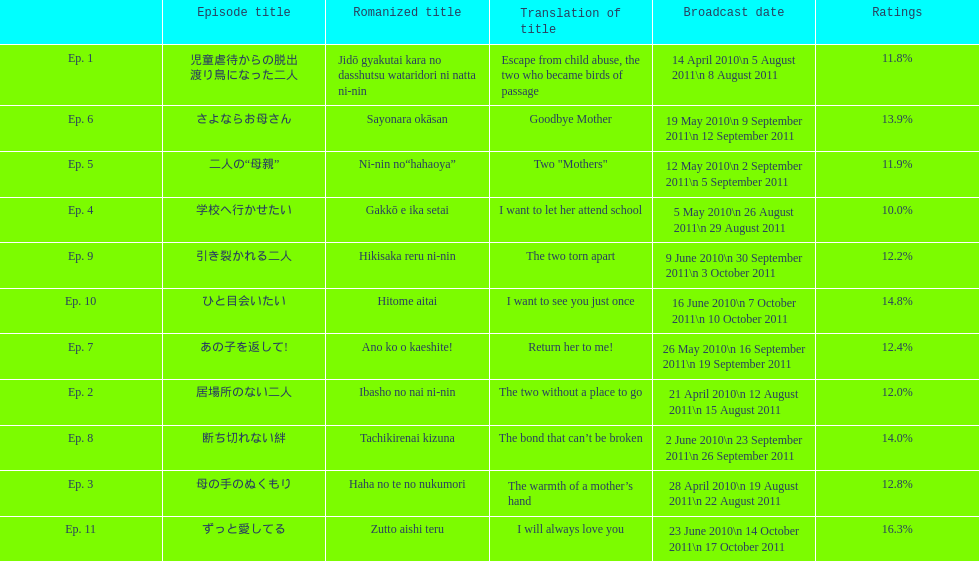What was the name of the next episode after goodbye mother? あの子を返して!. 